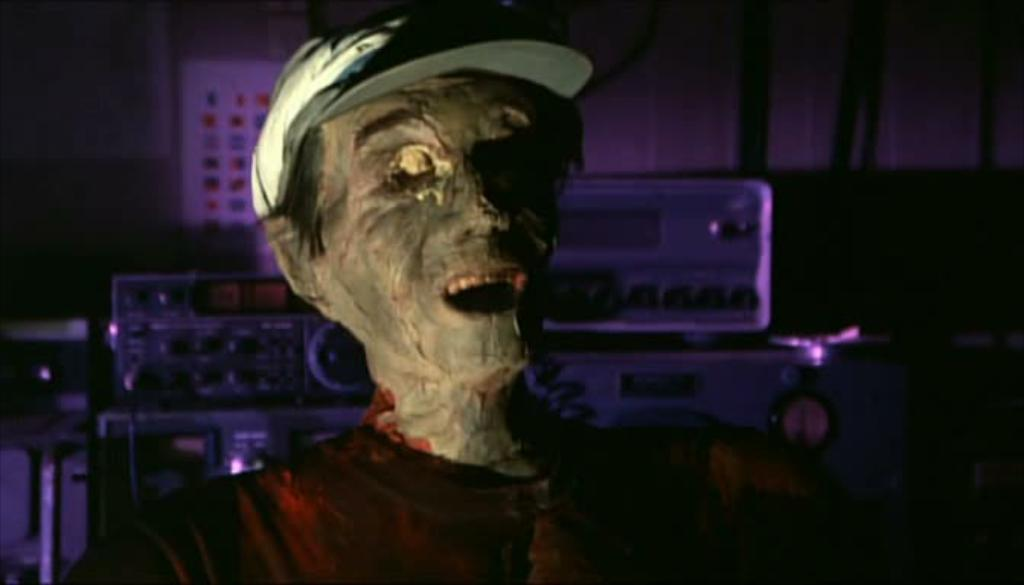What is the main subject in the center of the image? There is a sculpture in the center of the image. What can be seen in the background of the image? There are instruments and some objects in the background of the image. Can you see the moon in the image? The moon is not present in the image. Are there any lizards attacking the sculpture in the image? There are no lizards or any signs of an attack in the image. 